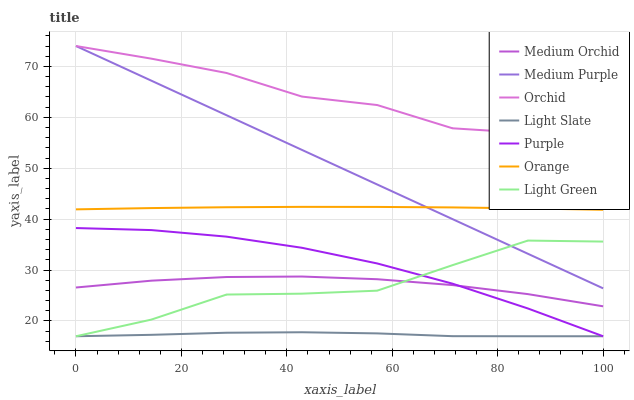Does Light Slate have the minimum area under the curve?
Answer yes or no. Yes. Does Orchid have the maximum area under the curve?
Answer yes or no. Yes. Does Medium Orchid have the minimum area under the curve?
Answer yes or no. No. Does Medium Orchid have the maximum area under the curve?
Answer yes or no. No. Is Medium Purple the smoothest?
Answer yes or no. Yes. Is Light Green the roughest?
Answer yes or no. Yes. Is Medium Orchid the smoothest?
Answer yes or no. No. Is Medium Orchid the roughest?
Answer yes or no. No. Does Light Slate have the lowest value?
Answer yes or no. Yes. Does Medium Orchid have the lowest value?
Answer yes or no. No. Does Orchid have the highest value?
Answer yes or no. Yes. Does Medium Orchid have the highest value?
Answer yes or no. No. Is Light Slate less than Medium Orchid?
Answer yes or no. Yes. Is Medium Purple greater than Purple?
Answer yes or no. Yes. Does Purple intersect Medium Orchid?
Answer yes or no. Yes. Is Purple less than Medium Orchid?
Answer yes or no. No. Is Purple greater than Medium Orchid?
Answer yes or no. No. Does Light Slate intersect Medium Orchid?
Answer yes or no. No. 